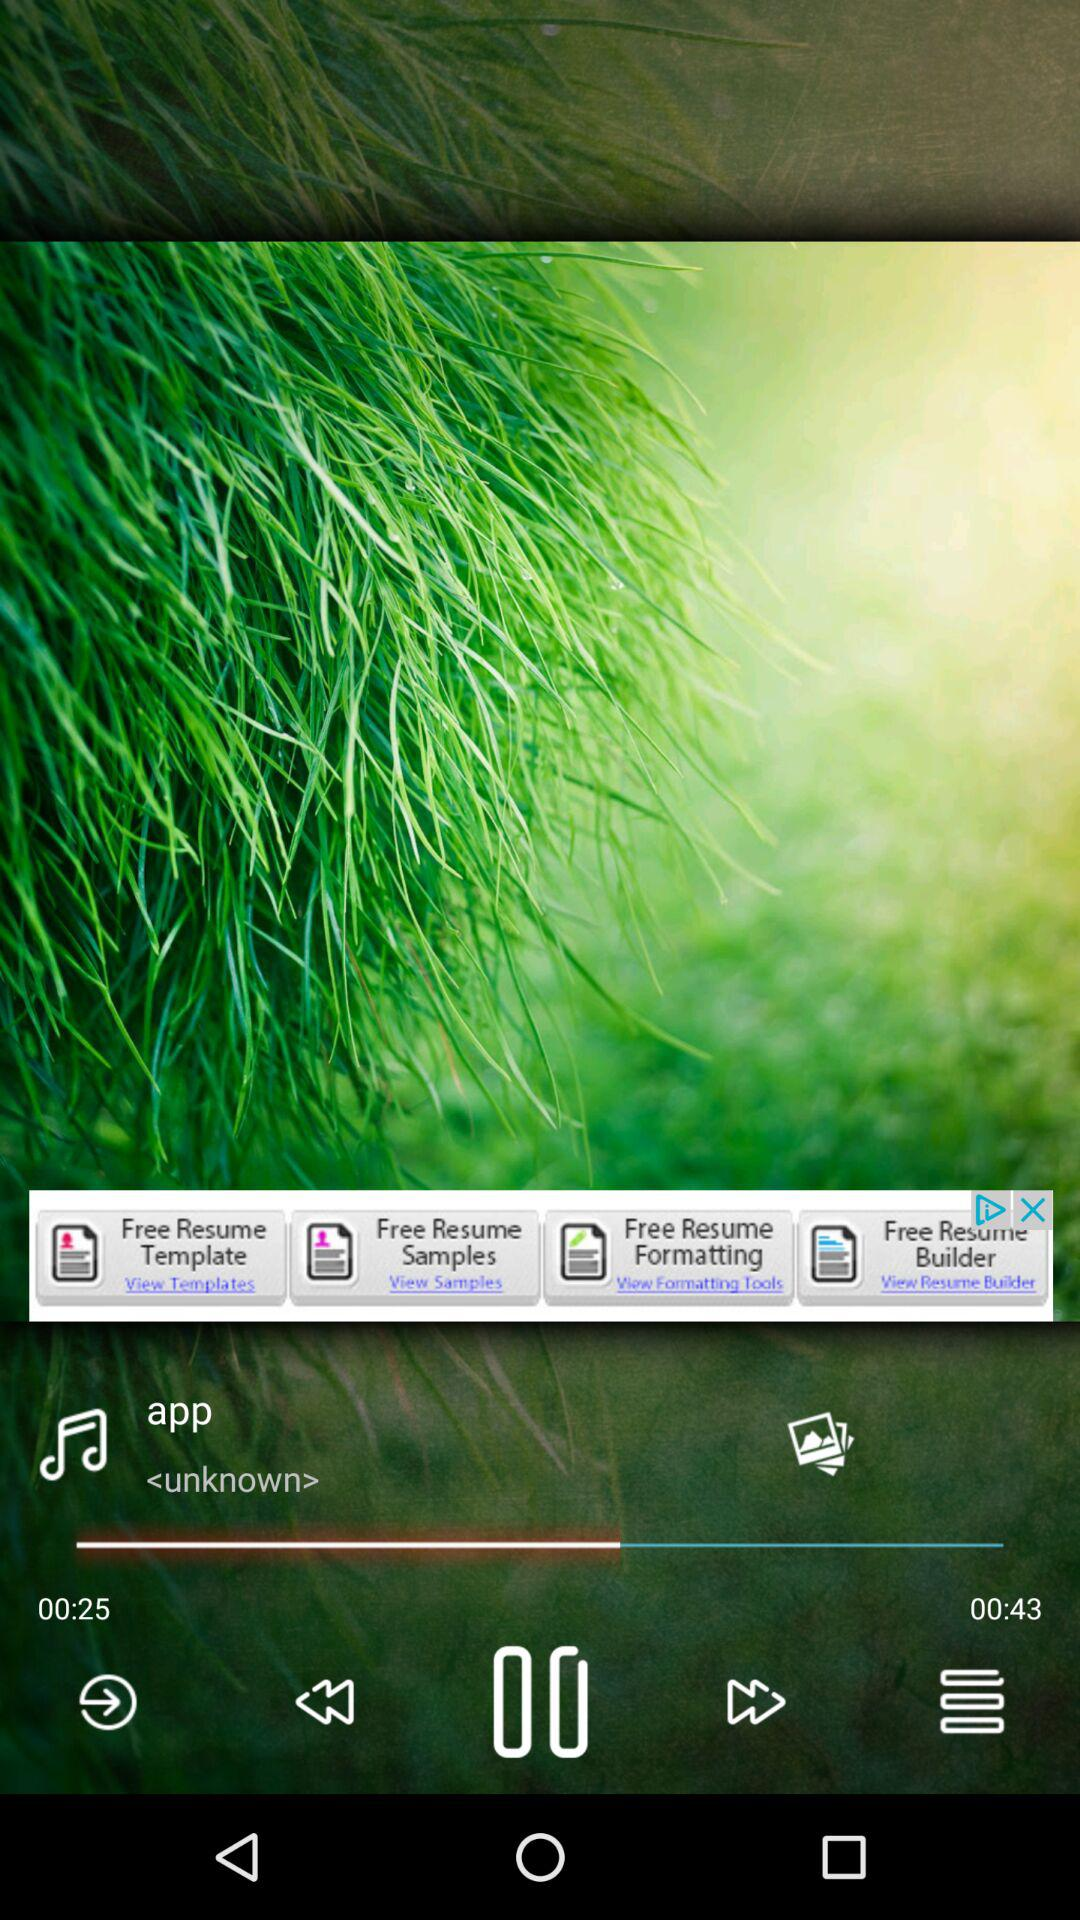How many more seconds are there in the time of 00:43 than in the time of 00:25?
Answer the question using a single word or phrase. 18 